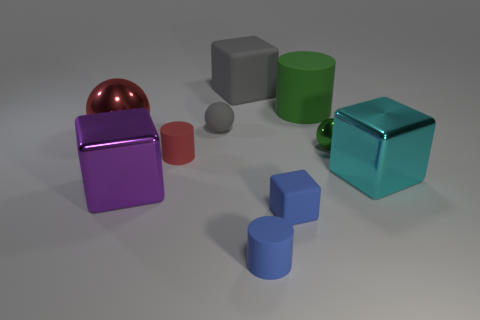Is the big gray block made of the same material as the tiny blue cylinder?
Make the answer very short. Yes. How many green rubber objects are to the left of the red thing that is to the left of the metallic block that is in front of the big cyan shiny thing?
Keep it short and to the point. 0. There is a matte cylinder that is behind the small green metallic ball; what color is it?
Provide a succinct answer. Green. There is a big metal thing that is to the right of the blue matte block that is to the right of the big sphere; what shape is it?
Your response must be concise. Cube. Is the big rubber cylinder the same color as the tiny rubber sphere?
Make the answer very short. No. How many cylinders are big things or large purple metallic objects?
Give a very brief answer. 1. There is a cylinder that is both in front of the big green matte thing and behind the tiny cube; what material is it?
Offer a very short reply. Rubber. What number of tiny red rubber cylinders are in front of the cyan thing?
Give a very brief answer. 0. Are the blue thing that is in front of the tiny rubber cube and the small ball that is right of the big cylinder made of the same material?
Provide a short and direct response. No. What number of things are big rubber things right of the tiny cube or tiny gray rubber blocks?
Provide a succinct answer. 1. 